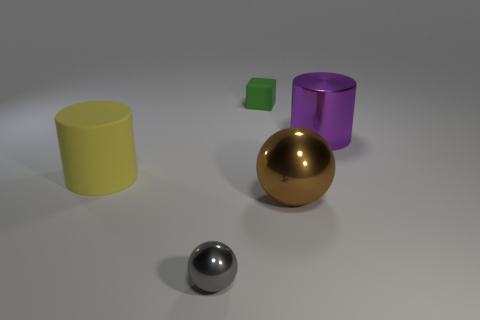Can you tell me the different materials that might be represented by the objects in the image? Certainly! Based on their appearances, the objects seem to mimic different materials: the yellow and purple cylinders appear matte, perhaps like colored plastic. The small green cube resembles a gemstone with its slightly translucent look. The gold sphere looks like it could be made of polished metal or gold, while the chrome sphere has a reflective surface suggesting it is made of a mirror-like material, possibly stainless steel. 